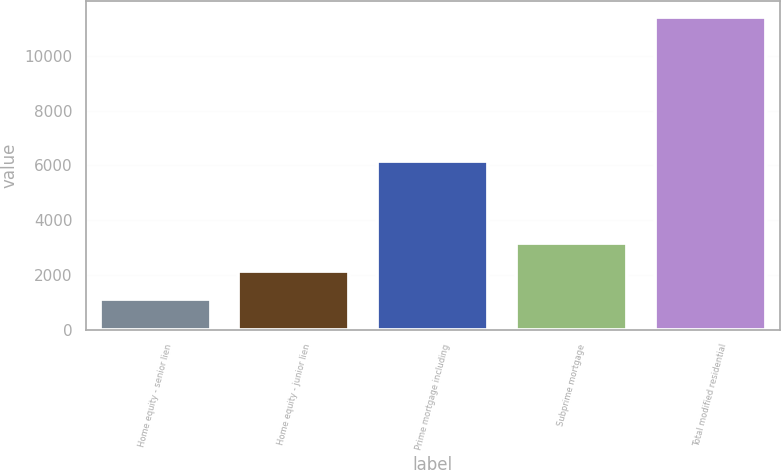Convert chart to OTSL. <chart><loc_0><loc_0><loc_500><loc_500><bar_chart><fcel>Home equity - senior lien<fcel>Home equity - junior lien<fcel>Prime mortgage including<fcel>Subprime mortgage<fcel>Total modified residential<nl><fcel>1101<fcel>2133.7<fcel>6145<fcel>3166.4<fcel>11428<nl></chart> 